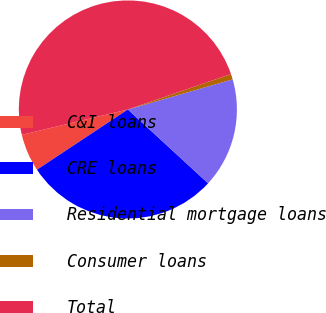Convert chart. <chart><loc_0><loc_0><loc_500><loc_500><pie_chart><fcel>C&I loans<fcel>CRE loans<fcel>Residential mortgage loans<fcel>Consumer loans<fcel>Total<nl><fcel>5.58%<fcel>28.85%<fcel>16.29%<fcel>0.81%<fcel>48.48%<nl></chart> 